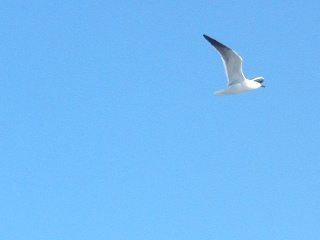Is the sky both bright and blue? Yes, the sky in the image is both bright and blue, indicating a sunny day. 